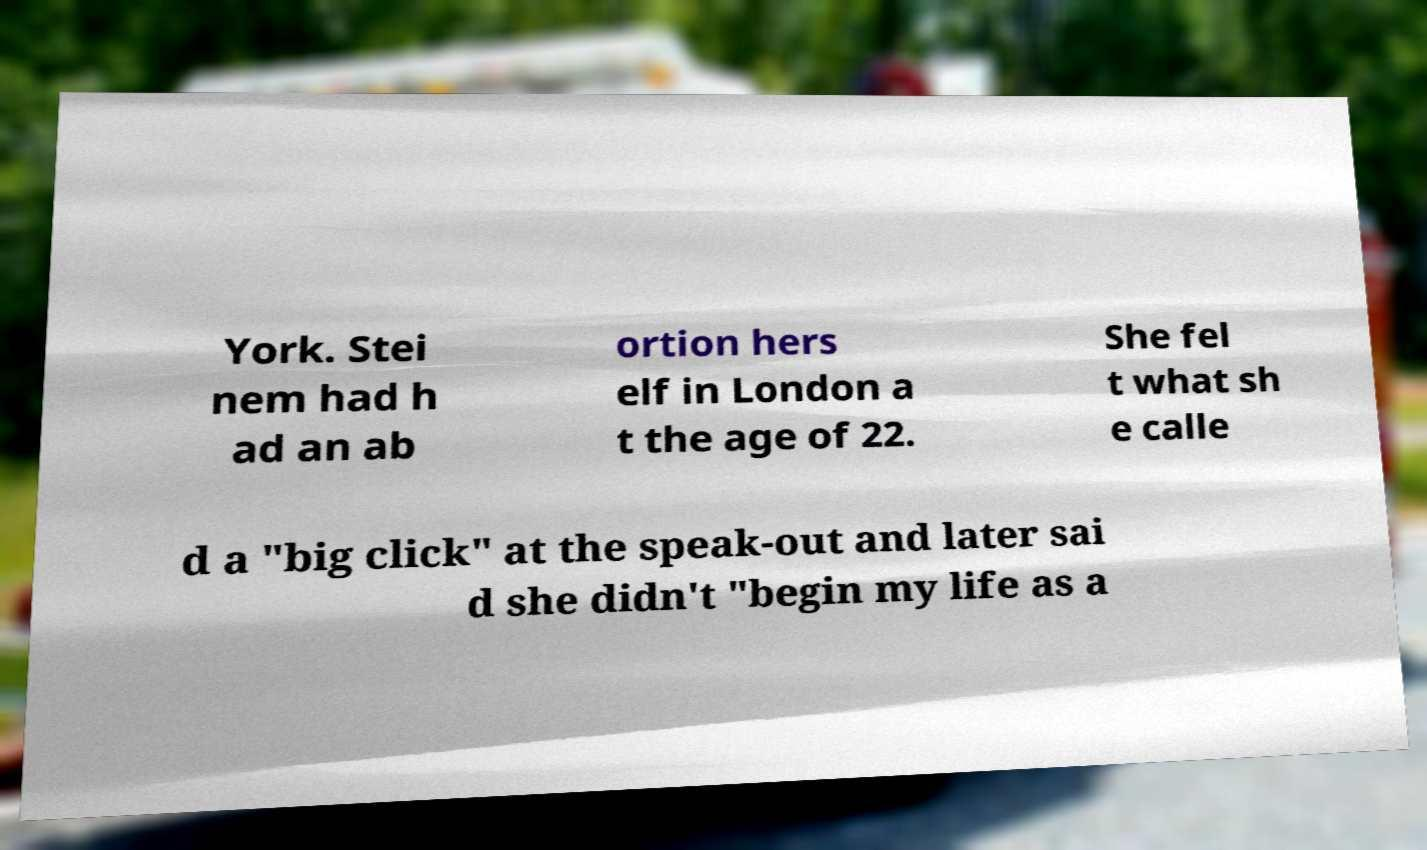There's text embedded in this image that I need extracted. Can you transcribe it verbatim? York. Stei nem had h ad an ab ortion hers elf in London a t the age of 22. She fel t what sh e calle d a "big click" at the speak-out and later sai d she didn't "begin my life as a 